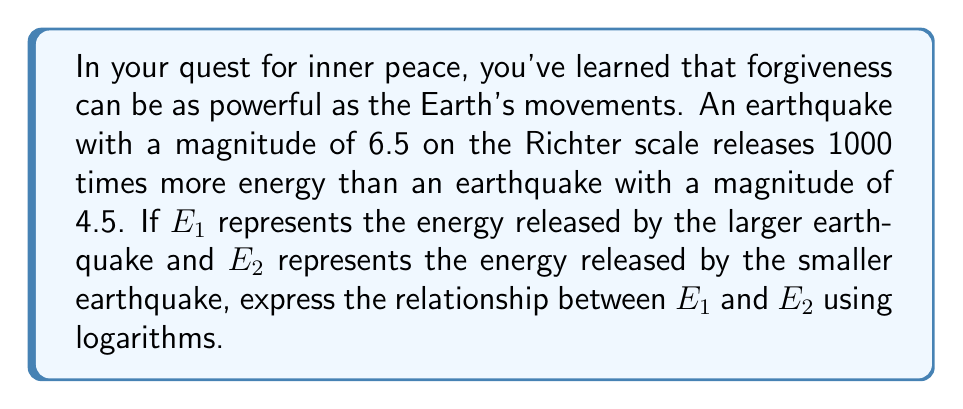Solve this math problem. Let's approach this step-by-step:

1) The Richter scale is logarithmic, based on the equation:
   $M = \log_{10}(A) + C$
   where $M$ is the magnitude, $A$ is the amplitude, and $C$ is a constant.

2) We're told that the difference in magnitude (6.5 - 4.5 = 2) corresponds to a 1000-fold increase in energy.

3) In general, for the Richter scale, a difference of 1 in magnitude corresponds to a 10-fold increase in ground motion amplitude, which correlates to about a 31.6-fold (√1000) increase in energy.

4) For a difference of 2 in magnitude, we square this: $31.6^2 = 1000$

5) We can express this relationship as:
   $\frac{E_1}{E_2} = 1000$

6) Taking the logarithm of both sides:
   $\log_{10}(\frac{E_1}{E_2}) = \log_{10}(1000)$

7) Using the logarithm property $\log_a(\frac{x}{y}) = \log_a(x) - \log_a(y)$:
   $\log_{10}(E_1) - \log_{10}(E_2) = \log_{10}(1000) = 3$

8) Therefore, the relationship can be expressed as:
   $\log_{10}(E_1) = \log_{10}(E_2) + 3$

This equation shows how the energies of the two earthquakes are related logarithmically, reflecting the nature of the Richter scale.
Answer: $\log_{10}(E_1) = \log_{10}(E_2) + 3$ 